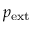<formula> <loc_0><loc_0><loc_500><loc_500>p _ { e x t }</formula> 